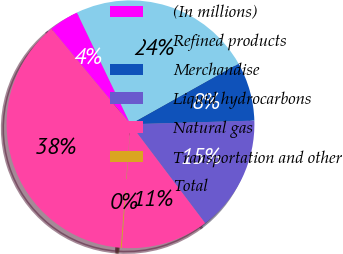Convert chart to OTSL. <chart><loc_0><loc_0><loc_500><loc_500><pie_chart><fcel>(In millions)<fcel>Refined products<fcel>Merchandise<fcel>Liquid hydrocarbons<fcel>Natural gas<fcel>Transportation and other<fcel>Total<nl><fcel>3.9%<fcel>23.99%<fcel>7.66%<fcel>15.18%<fcel>11.42%<fcel>0.14%<fcel>37.73%<nl></chart> 